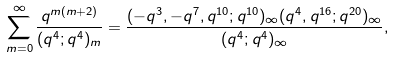<formula> <loc_0><loc_0><loc_500><loc_500>\sum _ { m = 0 } ^ { \infty } \frac { q ^ { m ( m + 2 ) } } { ( q ^ { 4 } ; q ^ { 4 } ) _ { m } } = \frac { ( - q ^ { 3 } , - q ^ { 7 } , q ^ { 1 0 } ; q ^ { 1 0 } ) _ { \infty } ( q ^ { 4 } , q ^ { 1 6 } ; q ^ { 2 0 } ) _ { \infty } } { ( q ^ { 4 } ; q ^ { 4 } ) _ { \infty } } ,</formula> 